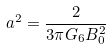Convert formula to latex. <formula><loc_0><loc_0><loc_500><loc_500>a ^ { 2 } = \frac { 2 } { 3 \pi G _ { 6 } B _ { 0 } ^ { 2 } }</formula> 